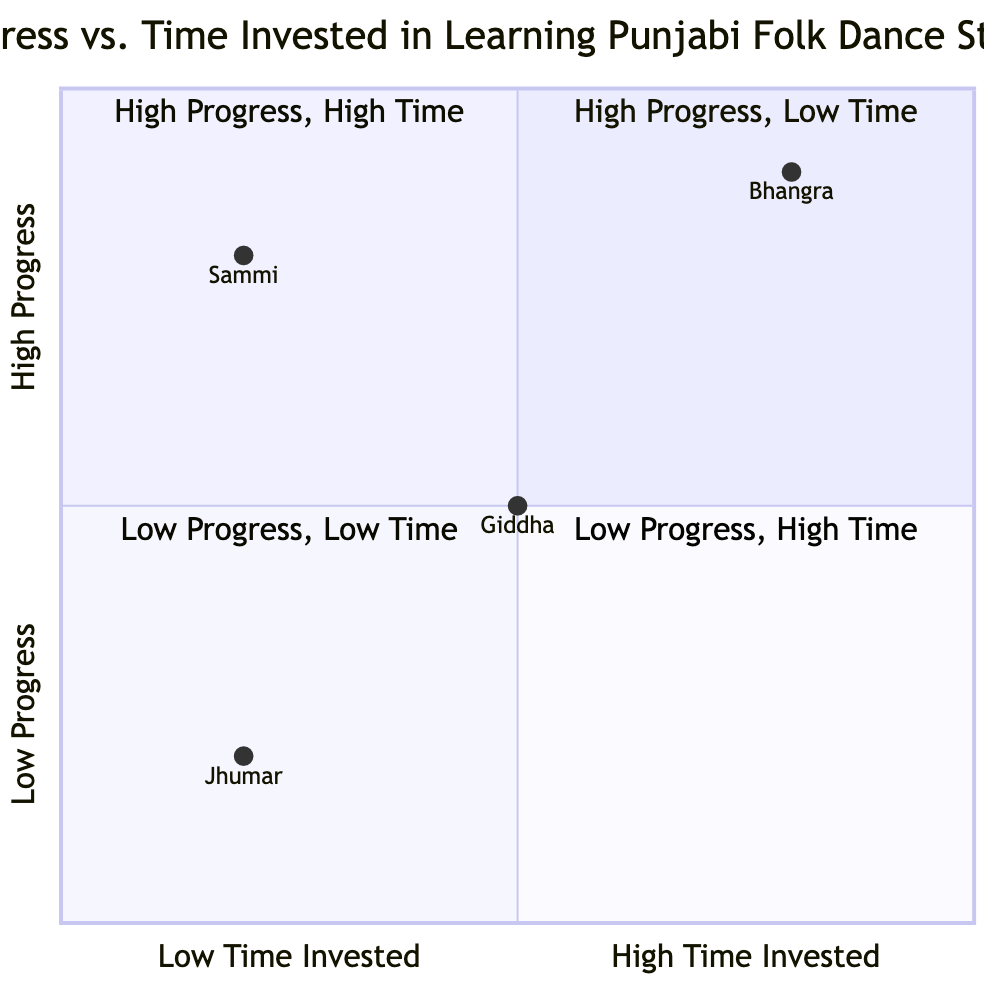What is the dance style with high progress and low time invested? The quadrant chart shows that the style "Sammi" is positioned in Quadrant 1 (High Progress, Low Time). Therefore, this is the dance style that meets the criteria asked in the question.
Answer: Sammi How many dance styles are plotted in the diagram? The data includes four dance styles: Bhangra, Giddha, Jhumar, and Sammi. Thus, by counting the styles presented, the total is four dance styles plotted in the quadrant chart.
Answer: 4 Which dance style has the highest time invested? Analyzing the quadrant placements, "Bhangra" is located in Quadrant 2 (High Progress, High Time), indicating it has the highest time invested compared to the other dance styles in the chart.
Answer: Bhangra What is the progress level of Giddha? The position of Giddha in the quadrant chart indicates it falls in Quadrant 2 (Medium Progress, Medium Time), which reflects a medium level of progress for this dance style.
Answer: Medium Which dance style has low progress and low time invested? Jhumar is placed in Quadrant 3 (Low Progress, Low Time) according to the chart, meaning it is the dance style with both low progress and low time invested.
Answer: Jhumar In which quadrant is Bhangra located? The chart shows Bhangra positioned in Quadrant 2 where high progress aligns with high time invested, identifying it as a style that requires significant time to achieve a high level of progress.
Answer: Quadrant 2 What is the time invested for Sammi? Sammi is located in Quadrant 1 (High Progress, Low Time), indicating that the time invested for this dance style is low according to its placement in the chart.
Answer: Low How does Jhumar's progress compare to Giddha's? Jhumar is placed in Quadrant 3 (Low Progress, Low Time), while Giddha is in Quadrant 2 (Medium Progress, Medium Time). As such, Giddha has a higher level of progress compared to Jhumar.
Answer: Giddha is higher Which dance style has the lowest progress? The analysis shows that Jhumar, positioned in Quadrant 3, has the lowest progress as indicated by its placement in the diagram.
Answer: Jhumar 